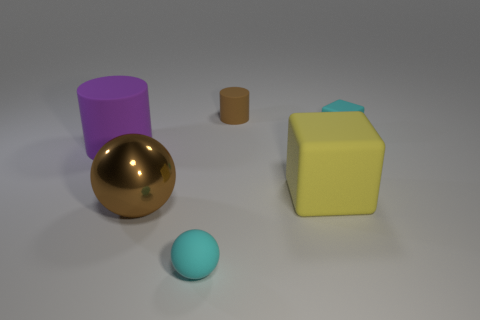There is a cyan thing that is in front of the big purple matte thing; is its shape the same as the brown rubber object?
Ensure brevity in your answer.  No. Is the brown metal thing the same shape as the tiny brown matte thing?
Your answer should be compact. No. What number of shiny objects are either large cylinders or large brown things?
Ensure brevity in your answer.  1. There is a thing that is the same color as the small sphere; what is its material?
Provide a short and direct response. Rubber. Do the brown matte cylinder and the purple matte thing have the same size?
Give a very brief answer. No. How many objects are either big yellow matte objects or cyan objects that are on the right side of the yellow rubber thing?
Provide a succinct answer. 2. There is a brown thing that is the same size as the yellow rubber object; what is its material?
Offer a terse response. Metal. What material is the object that is both in front of the yellow cube and right of the large brown sphere?
Ensure brevity in your answer.  Rubber. Is there a brown metal sphere that is behind the brown object that is in front of the big cylinder?
Ensure brevity in your answer.  No. What size is the object that is both on the left side of the small matte cylinder and to the right of the shiny sphere?
Provide a short and direct response. Small. 